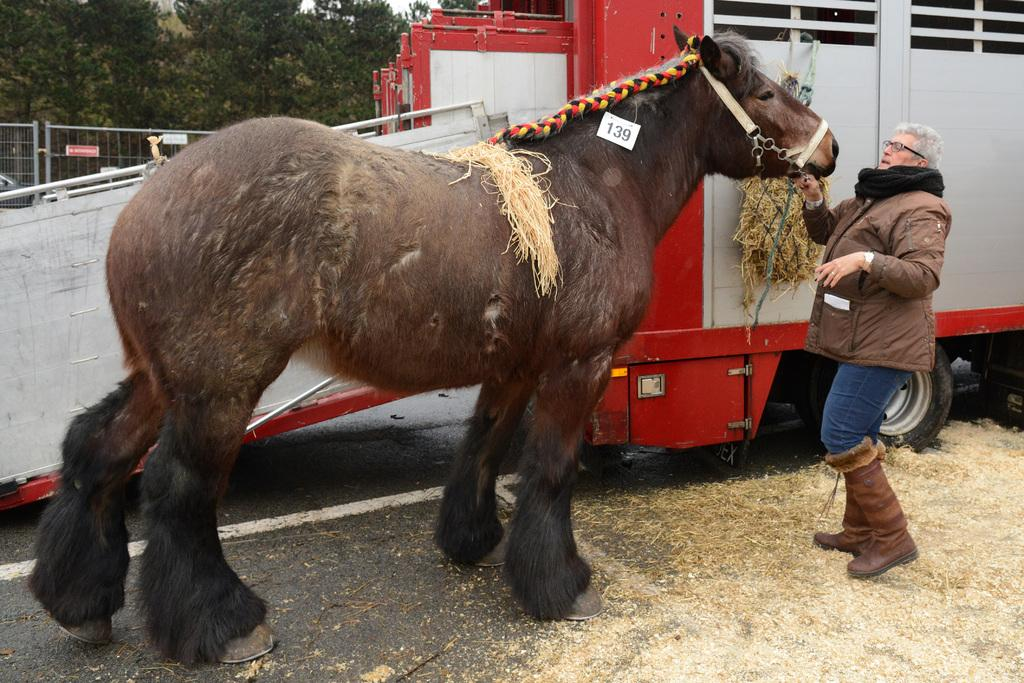What is the main subject of the image? There is a person in the image. What is the person doing in the image? The person is holding a horse. What can be seen in the background of the image? There is a vehicle and trees in the background of the image. What type of cushion is placed on the door in the image? There is no cushion or door present in the image. 